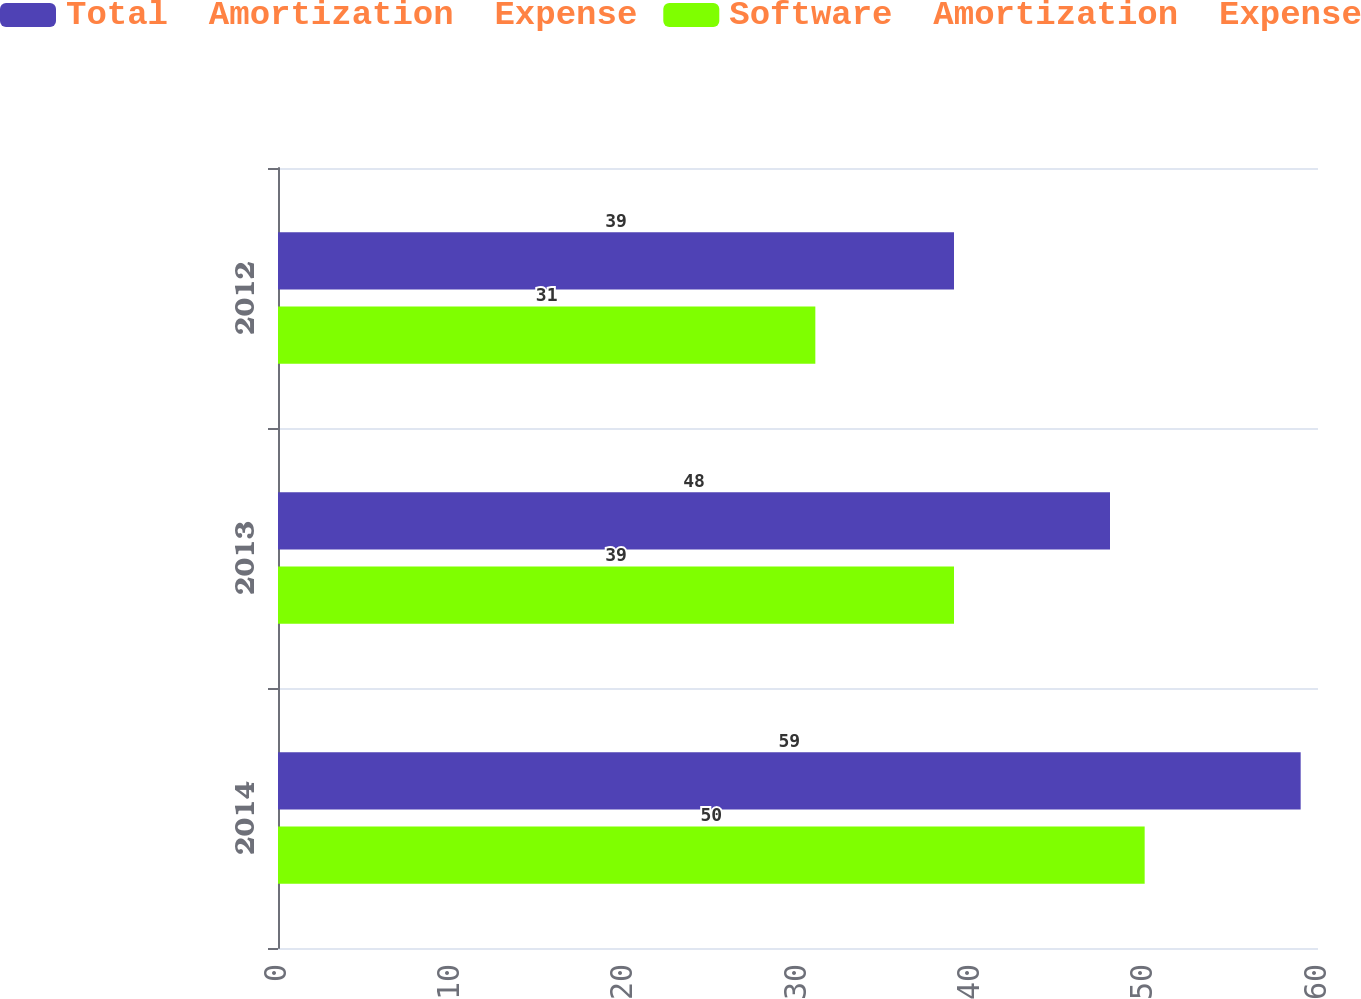<chart> <loc_0><loc_0><loc_500><loc_500><stacked_bar_chart><ecel><fcel>2014<fcel>2013<fcel>2012<nl><fcel>Total  Amortization  Expense<fcel>59<fcel>48<fcel>39<nl><fcel>Software  Amortization  Expense<fcel>50<fcel>39<fcel>31<nl></chart> 